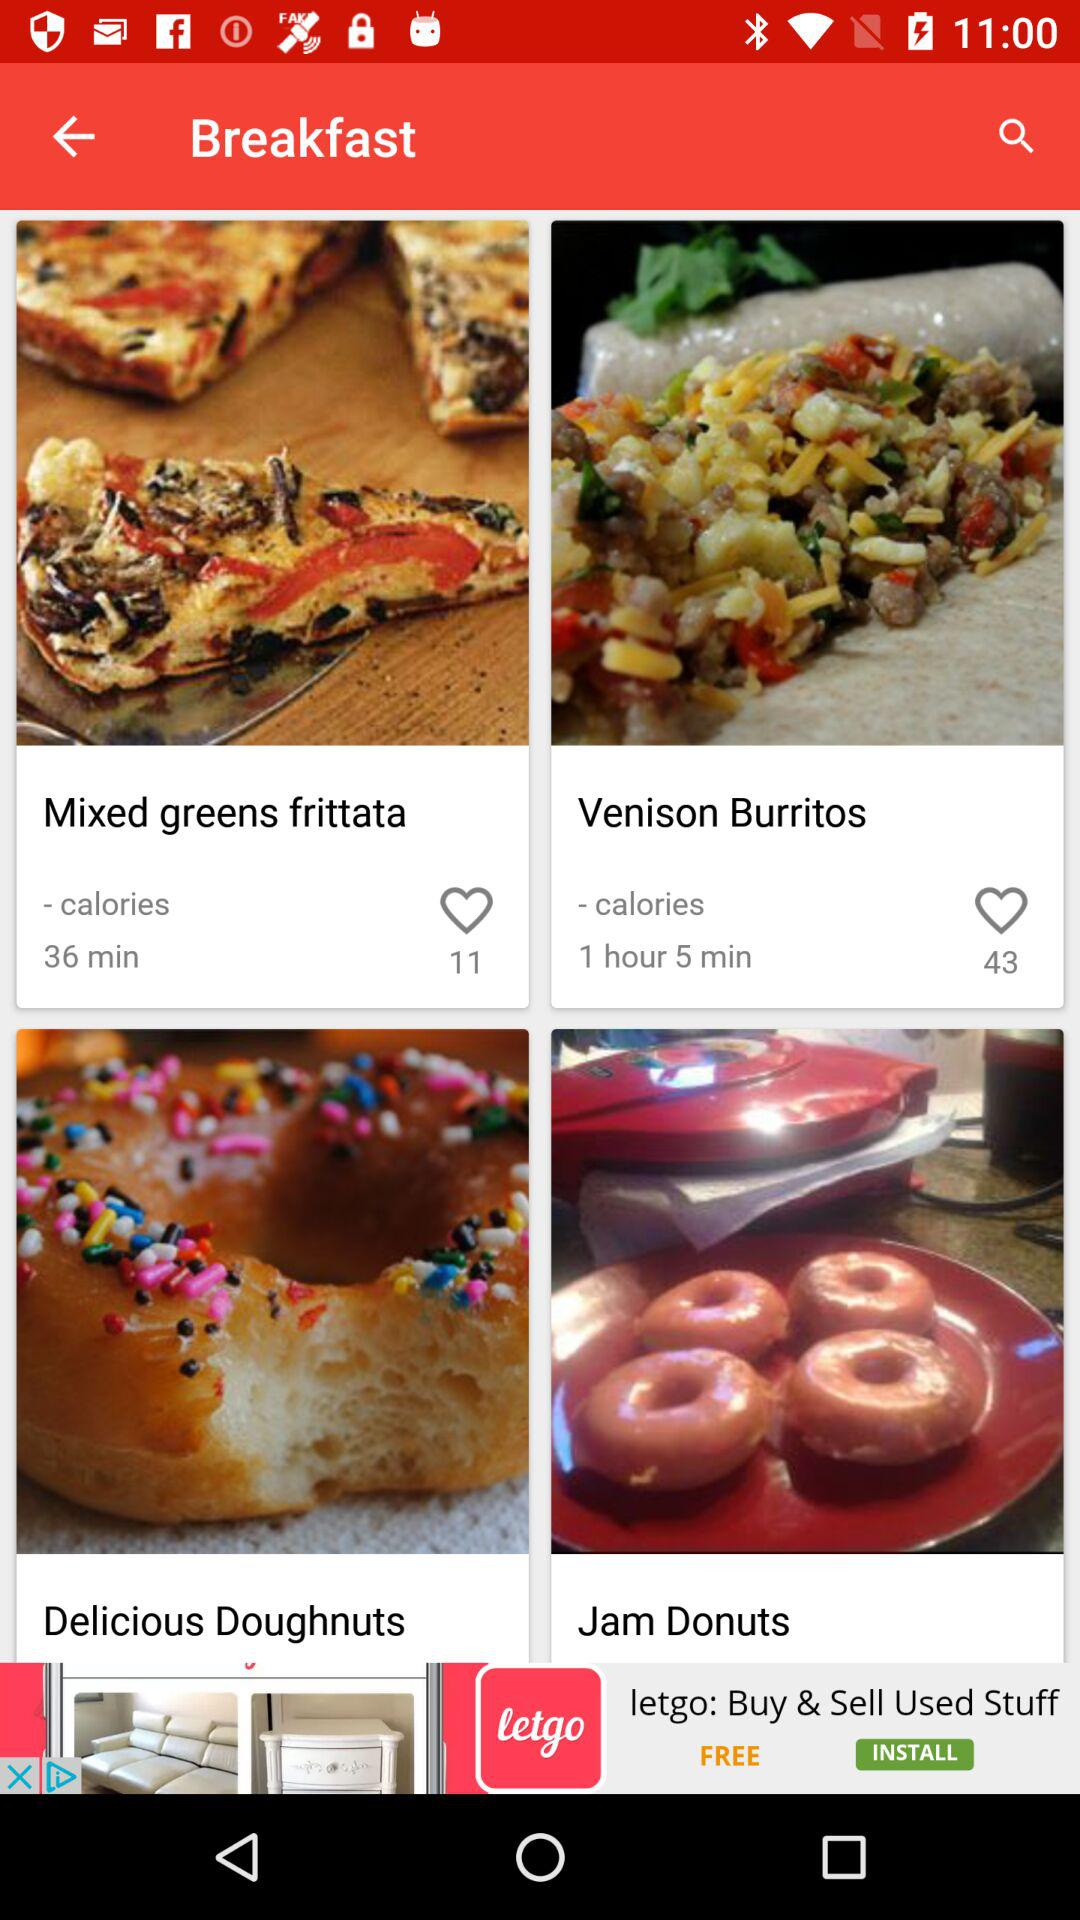What is the preparation time for "Venison Burritos"? The preparation time is 1 hour and 5 minutes. 